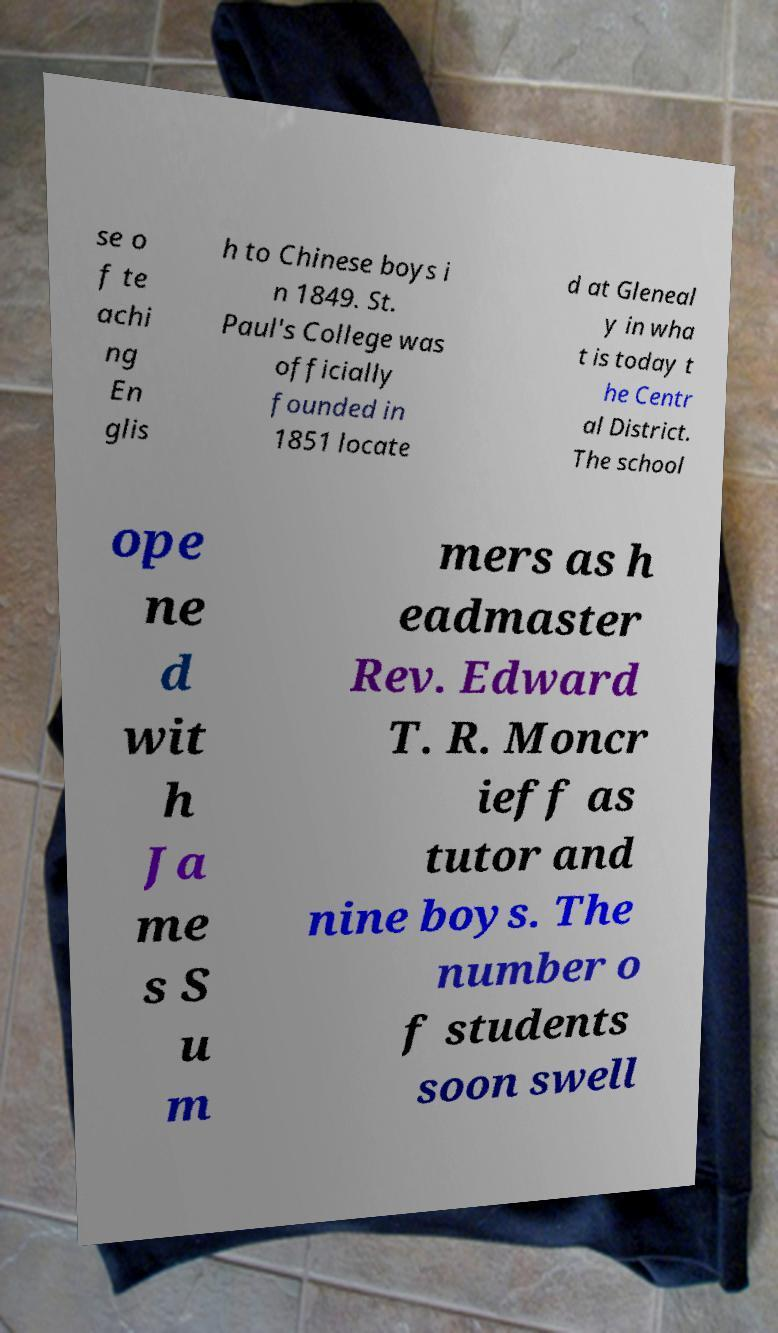What messages or text are displayed in this image? I need them in a readable, typed format. se o f te achi ng En glis h to Chinese boys i n 1849. St. Paul's College was officially founded in 1851 locate d at Gleneal y in wha t is today t he Centr al District. The school ope ne d wit h Ja me s S u m mers as h eadmaster Rev. Edward T. R. Moncr ieff as tutor and nine boys. The number o f students soon swell 